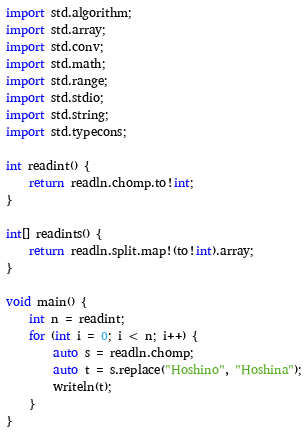Convert code to text. <code><loc_0><loc_0><loc_500><loc_500><_D_>import std.algorithm;
import std.array;
import std.conv;
import std.math;
import std.range;
import std.stdio;
import std.string;
import std.typecons;

int readint() {
    return readln.chomp.to!int;
}

int[] readints() {
    return readln.split.map!(to!int).array;
}

void main() {
    int n = readint;
    for (int i = 0; i < n; i++) {
        auto s = readln.chomp;
        auto t = s.replace("Hoshino", "Hoshina");
        writeln(t);
    }
}</code> 